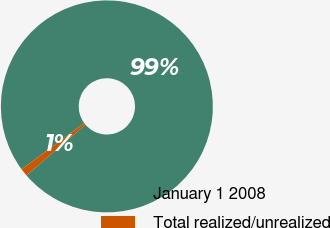Convert chart to OTSL. <chart><loc_0><loc_0><loc_500><loc_500><pie_chart><fcel>January 1 2008<fcel>Total realized/unrealized<nl><fcel>98.83%<fcel>1.17%<nl></chart> 